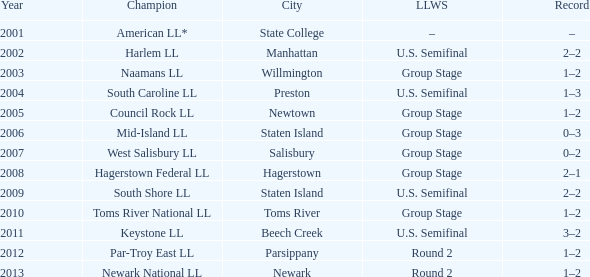Which edition of the little league world series was held in parsippany? Round 2. 